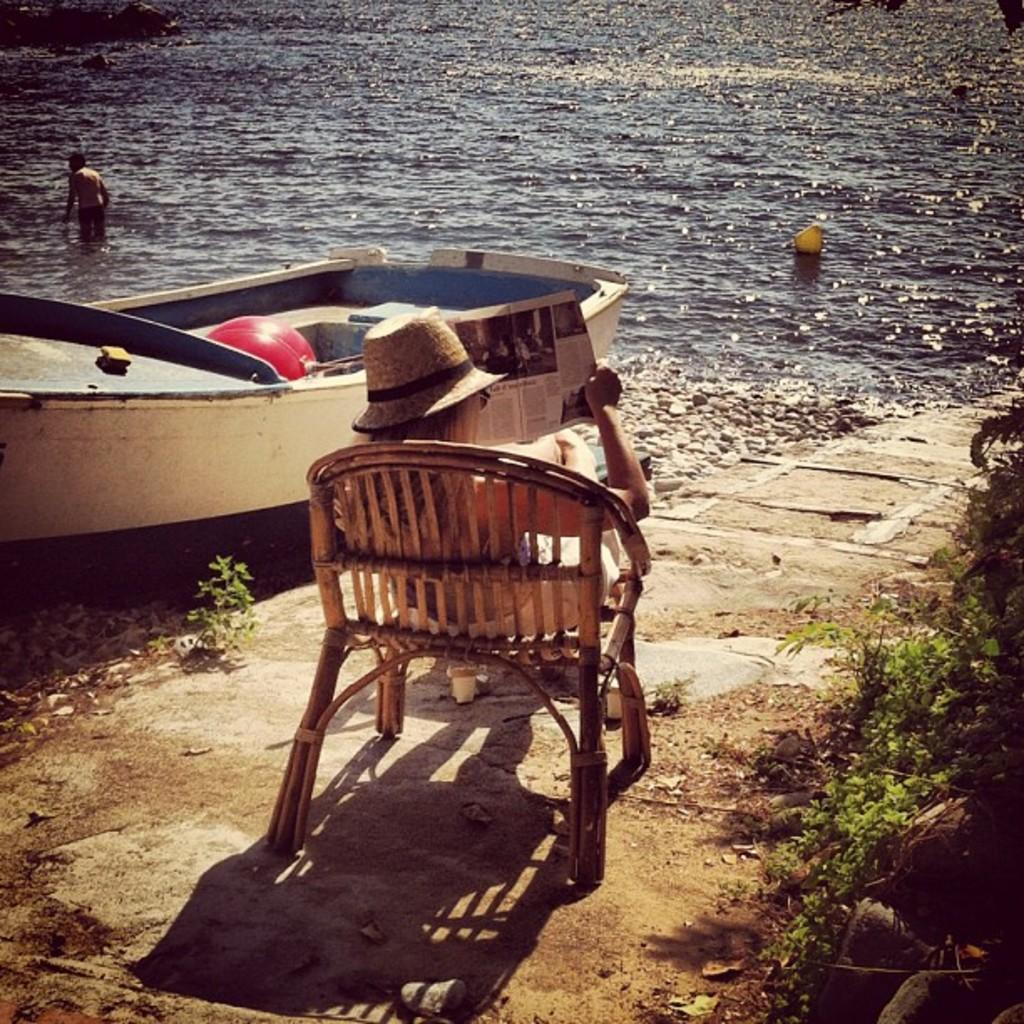What is the man doing in the image? The man is in a river in the image. What else can be seen in the image besides the man in the river? There is a boat and a woman sitting on a chair in the image. What is the woman doing in the image? The woman is sitting on a chair and reading a newspaper. What type of surface can be seen in the image? There are pebbles visible in the image. What type of vegetation is present in the image? There are plants in the image. What type of wire is being used to hold the branch in the image? There is no branch or wire present in the image. What is the purpose of the boat in the image? The purpose of the boat in the image cannot be determined from the provided facts. 